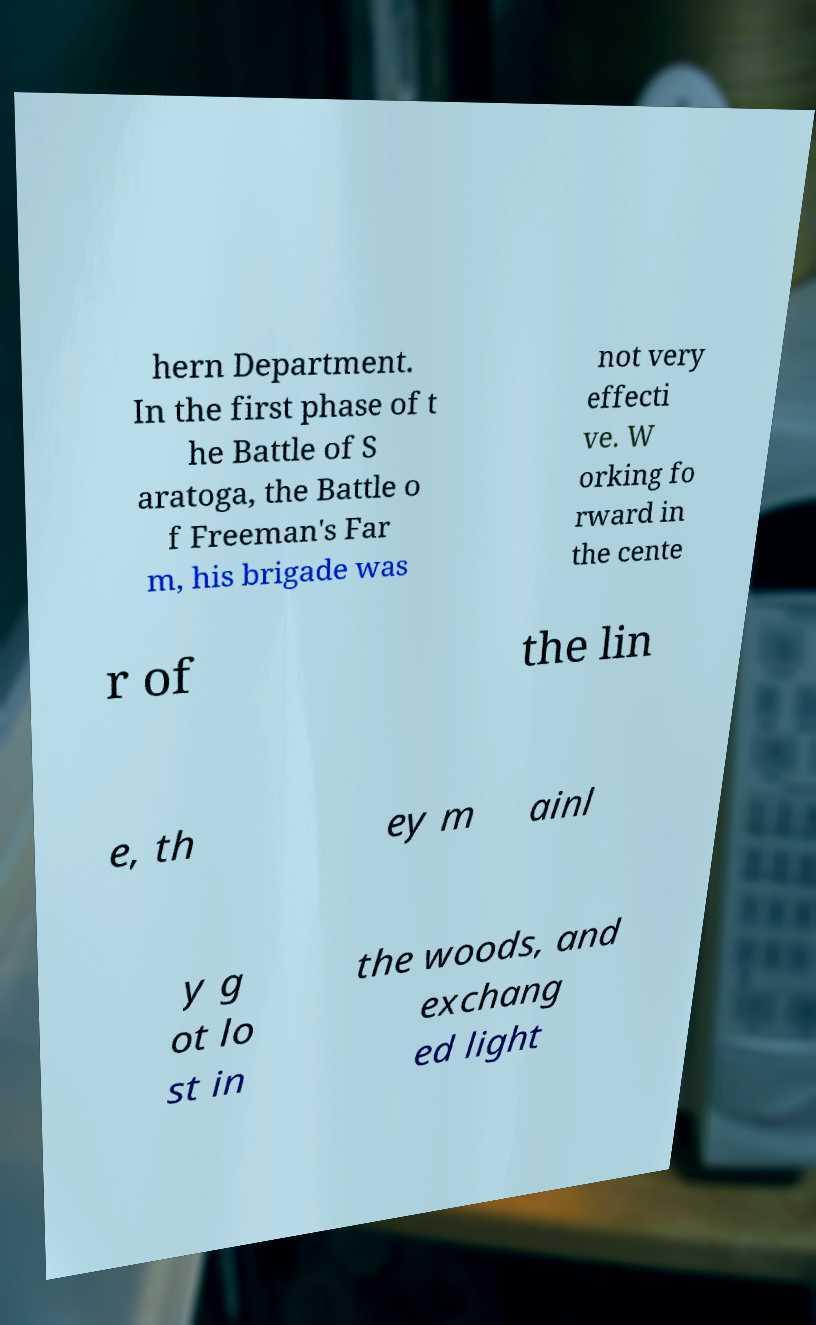Could you assist in decoding the text presented in this image and type it out clearly? hern Department. In the first phase of t he Battle of S aratoga, the Battle o f Freeman's Far m, his brigade was not very effecti ve. W orking fo rward in the cente r of the lin e, th ey m ainl y g ot lo st in the woods, and exchang ed light 